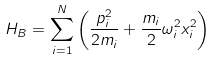Convert formula to latex. <formula><loc_0><loc_0><loc_500><loc_500>H _ { B } = \sum _ { i = 1 } ^ { N } \left ( \frac { p _ { i } ^ { 2 } } { 2 m _ { i } } + \frac { m _ { i } } { 2 } \omega _ { i } ^ { 2 } x _ { i } ^ { 2 } \right )</formula> 